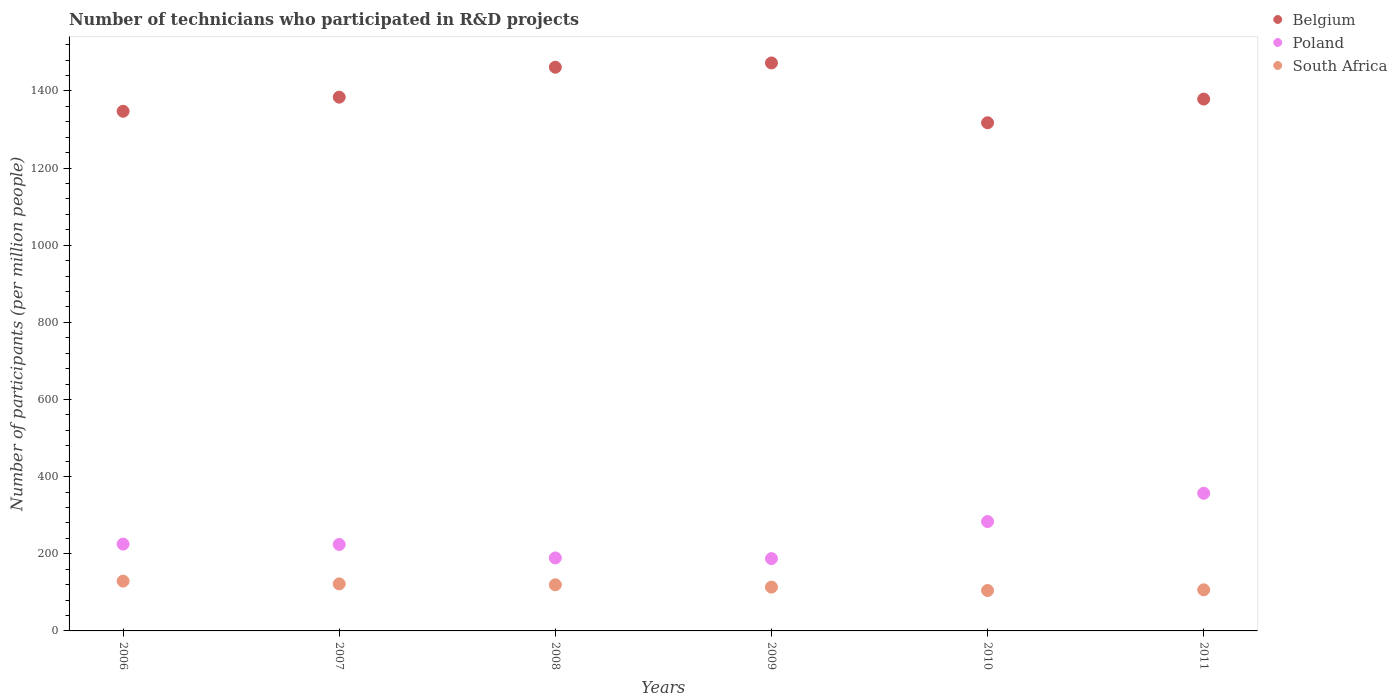What is the number of technicians who participated in R&D projects in South Africa in 2009?
Make the answer very short. 113.59. Across all years, what is the maximum number of technicians who participated in R&D projects in Belgium?
Provide a short and direct response. 1472.61. Across all years, what is the minimum number of technicians who participated in R&D projects in Poland?
Ensure brevity in your answer.  187.5. What is the total number of technicians who participated in R&D projects in Poland in the graph?
Your response must be concise. 1466.48. What is the difference between the number of technicians who participated in R&D projects in Belgium in 2006 and that in 2009?
Make the answer very short. -125.25. What is the difference between the number of technicians who participated in R&D projects in Poland in 2006 and the number of technicians who participated in R&D projects in South Africa in 2011?
Provide a succinct answer. 118.53. What is the average number of technicians who participated in R&D projects in South Africa per year?
Give a very brief answer. 115.94. In the year 2006, what is the difference between the number of technicians who participated in R&D projects in Poland and number of technicians who participated in R&D projects in Belgium?
Your answer should be compact. -1122.26. What is the ratio of the number of technicians who participated in R&D projects in Belgium in 2006 to that in 2009?
Give a very brief answer. 0.91. Is the number of technicians who participated in R&D projects in Poland in 2009 less than that in 2010?
Give a very brief answer. Yes. Is the difference between the number of technicians who participated in R&D projects in Poland in 2006 and 2009 greater than the difference between the number of technicians who participated in R&D projects in Belgium in 2006 and 2009?
Provide a succinct answer. Yes. What is the difference between the highest and the second highest number of technicians who participated in R&D projects in Belgium?
Provide a succinct answer. 11.08. What is the difference between the highest and the lowest number of technicians who participated in R&D projects in South Africa?
Your answer should be very brief. 24.35. In how many years, is the number of technicians who participated in R&D projects in Poland greater than the average number of technicians who participated in R&D projects in Poland taken over all years?
Your response must be concise. 2. Is the number of technicians who participated in R&D projects in Poland strictly less than the number of technicians who participated in R&D projects in South Africa over the years?
Provide a short and direct response. No. How many years are there in the graph?
Keep it short and to the point. 6. What is the difference between two consecutive major ticks on the Y-axis?
Ensure brevity in your answer.  200. Does the graph contain grids?
Provide a short and direct response. No. How are the legend labels stacked?
Your response must be concise. Vertical. What is the title of the graph?
Give a very brief answer. Number of technicians who participated in R&D projects. What is the label or title of the Y-axis?
Ensure brevity in your answer.  Number of participants (per million people). What is the Number of participants (per million people) in Belgium in 2006?
Your response must be concise. 1347.37. What is the Number of participants (per million people) in Poland in 2006?
Offer a very short reply. 225.1. What is the Number of participants (per million people) in South Africa in 2006?
Give a very brief answer. 129.14. What is the Number of participants (per million people) in Belgium in 2007?
Provide a short and direct response. 1383.94. What is the Number of participants (per million people) in Poland in 2007?
Give a very brief answer. 224.18. What is the Number of participants (per million people) of South Africa in 2007?
Make the answer very short. 121.96. What is the Number of participants (per million people) in Belgium in 2008?
Ensure brevity in your answer.  1461.53. What is the Number of participants (per million people) in Poland in 2008?
Your answer should be very brief. 189.22. What is the Number of participants (per million people) of South Africa in 2008?
Your response must be concise. 119.61. What is the Number of participants (per million people) of Belgium in 2009?
Keep it short and to the point. 1472.61. What is the Number of participants (per million people) in Poland in 2009?
Give a very brief answer. 187.5. What is the Number of participants (per million people) in South Africa in 2009?
Offer a terse response. 113.59. What is the Number of participants (per million people) of Belgium in 2010?
Provide a succinct answer. 1317.54. What is the Number of participants (per million people) of Poland in 2010?
Offer a terse response. 283.57. What is the Number of participants (per million people) of South Africa in 2010?
Provide a short and direct response. 104.79. What is the Number of participants (per million people) in Belgium in 2011?
Keep it short and to the point. 1378.98. What is the Number of participants (per million people) in Poland in 2011?
Your answer should be very brief. 356.91. What is the Number of participants (per million people) in South Africa in 2011?
Your answer should be very brief. 106.57. Across all years, what is the maximum Number of participants (per million people) in Belgium?
Provide a succinct answer. 1472.61. Across all years, what is the maximum Number of participants (per million people) of Poland?
Your answer should be compact. 356.91. Across all years, what is the maximum Number of participants (per million people) in South Africa?
Keep it short and to the point. 129.14. Across all years, what is the minimum Number of participants (per million people) of Belgium?
Keep it short and to the point. 1317.54. Across all years, what is the minimum Number of participants (per million people) in Poland?
Your answer should be very brief. 187.5. Across all years, what is the minimum Number of participants (per million people) in South Africa?
Keep it short and to the point. 104.79. What is the total Number of participants (per million people) of Belgium in the graph?
Provide a succinct answer. 8361.97. What is the total Number of participants (per million people) in Poland in the graph?
Offer a terse response. 1466.48. What is the total Number of participants (per million people) of South Africa in the graph?
Provide a succinct answer. 695.67. What is the difference between the Number of participants (per million people) of Belgium in 2006 and that in 2007?
Offer a terse response. -36.57. What is the difference between the Number of participants (per million people) of Poland in 2006 and that in 2007?
Offer a terse response. 0.92. What is the difference between the Number of participants (per million people) of South Africa in 2006 and that in 2007?
Offer a very short reply. 7.19. What is the difference between the Number of participants (per million people) in Belgium in 2006 and that in 2008?
Offer a terse response. -114.17. What is the difference between the Number of participants (per million people) in Poland in 2006 and that in 2008?
Provide a succinct answer. 35.88. What is the difference between the Number of participants (per million people) of South Africa in 2006 and that in 2008?
Ensure brevity in your answer.  9.53. What is the difference between the Number of participants (per million people) of Belgium in 2006 and that in 2009?
Keep it short and to the point. -125.25. What is the difference between the Number of participants (per million people) of Poland in 2006 and that in 2009?
Your answer should be very brief. 37.6. What is the difference between the Number of participants (per million people) of South Africa in 2006 and that in 2009?
Your response must be concise. 15.55. What is the difference between the Number of participants (per million people) in Belgium in 2006 and that in 2010?
Offer a terse response. 29.83. What is the difference between the Number of participants (per million people) in Poland in 2006 and that in 2010?
Offer a terse response. -58.47. What is the difference between the Number of participants (per million people) in South Africa in 2006 and that in 2010?
Keep it short and to the point. 24.35. What is the difference between the Number of participants (per million people) of Belgium in 2006 and that in 2011?
Your response must be concise. -31.62. What is the difference between the Number of participants (per million people) in Poland in 2006 and that in 2011?
Provide a succinct answer. -131.81. What is the difference between the Number of participants (per million people) of South Africa in 2006 and that in 2011?
Give a very brief answer. 22.58. What is the difference between the Number of participants (per million people) in Belgium in 2007 and that in 2008?
Give a very brief answer. -77.6. What is the difference between the Number of participants (per million people) in Poland in 2007 and that in 2008?
Offer a terse response. 34.96. What is the difference between the Number of participants (per million people) of South Africa in 2007 and that in 2008?
Offer a very short reply. 2.34. What is the difference between the Number of participants (per million people) of Belgium in 2007 and that in 2009?
Provide a short and direct response. -88.68. What is the difference between the Number of participants (per million people) of Poland in 2007 and that in 2009?
Make the answer very short. 36.67. What is the difference between the Number of participants (per million people) in South Africa in 2007 and that in 2009?
Keep it short and to the point. 8.37. What is the difference between the Number of participants (per million people) of Belgium in 2007 and that in 2010?
Offer a terse response. 66.4. What is the difference between the Number of participants (per million people) in Poland in 2007 and that in 2010?
Your answer should be very brief. -59.39. What is the difference between the Number of participants (per million people) of South Africa in 2007 and that in 2010?
Ensure brevity in your answer.  17.16. What is the difference between the Number of participants (per million people) of Belgium in 2007 and that in 2011?
Your answer should be compact. 4.95. What is the difference between the Number of participants (per million people) in Poland in 2007 and that in 2011?
Provide a short and direct response. -132.73. What is the difference between the Number of participants (per million people) of South Africa in 2007 and that in 2011?
Ensure brevity in your answer.  15.39. What is the difference between the Number of participants (per million people) of Belgium in 2008 and that in 2009?
Offer a very short reply. -11.08. What is the difference between the Number of participants (per million people) in Poland in 2008 and that in 2009?
Keep it short and to the point. 1.72. What is the difference between the Number of participants (per million people) of South Africa in 2008 and that in 2009?
Offer a very short reply. 6.02. What is the difference between the Number of participants (per million people) of Belgium in 2008 and that in 2010?
Your answer should be compact. 144. What is the difference between the Number of participants (per million people) of Poland in 2008 and that in 2010?
Make the answer very short. -94.35. What is the difference between the Number of participants (per million people) in South Africa in 2008 and that in 2010?
Offer a very short reply. 14.82. What is the difference between the Number of participants (per million people) in Belgium in 2008 and that in 2011?
Your answer should be compact. 82.55. What is the difference between the Number of participants (per million people) of Poland in 2008 and that in 2011?
Give a very brief answer. -167.68. What is the difference between the Number of participants (per million people) in South Africa in 2008 and that in 2011?
Your response must be concise. 13.04. What is the difference between the Number of participants (per million people) in Belgium in 2009 and that in 2010?
Your answer should be very brief. 155.08. What is the difference between the Number of participants (per million people) of Poland in 2009 and that in 2010?
Offer a terse response. -96.07. What is the difference between the Number of participants (per million people) of South Africa in 2009 and that in 2010?
Give a very brief answer. 8.8. What is the difference between the Number of participants (per million people) of Belgium in 2009 and that in 2011?
Your response must be concise. 93.63. What is the difference between the Number of participants (per million people) in Poland in 2009 and that in 2011?
Ensure brevity in your answer.  -169.4. What is the difference between the Number of participants (per million people) of South Africa in 2009 and that in 2011?
Offer a very short reply. 7.02. What is the difference between the Number of participants (per million people) of Belgium in 2010 and that in 2011?
Make the answer very short. -61.45. What is the difference between the Number of participants (per million people) in Poland in 2010 and that in 2011?
Give a very brief answer. -73.34. What is the difference between the Number of participants (per million people) of South Africa in 2010 and that in 2011?
Offer a very short reply. -1.78. What is the difference between the Number of participants (per million people) in Belgium in 2006 and the Number of participants (per million people) in Poland in 2007?
Ensure brevity in your answer.  1123.19. What is the difference between the Number of participants (per million people) of Belgium in 2006 and the Number of participants (per million people) of South Africa in 2007?
Offer a terse response. 1225.41. What is the difference between the Number of participants (per million people) in Poland in 2006 and the Number of participants (per million people) in South Africa in 2007?
Provide a succinct answer. 103.14. What is the difference between the Number of participants (per million people) of Belgium in 2006 and the Number of participants (per million people) of Poland in 2008?
Your answer should be very brief. 1158.14. What is the difference between the Number of participants (per million people) in Belgium in 2006 and the Number of participants (per million people) in South Africa in 2008?
Provide a short and direct response. 1227.75. What is the difference between the Number of participants (per million people) of Poland in 2006 and the Number of participants (per million people) of South Africa in 2008?
Your answer should be compact. 105.49. What is the difference between the Number of participants (per million people) in Belgium in 2006 and the Number of participants (per million people) in Poland in 2009?
Offer a very short reply. 1159.86. What is the difference between the Number of participants (per million people) of Belgium in 2006 and the Number of participants (per million people) of South Africa in 2009?
Provide a short and direct response. 1233.78. What is the difference between the Number of participants (per million people) in Poland in 2006 and the Number of participants (per million people) in South Africa in 2009?
Keep it short and to the point. 111.51. What is the difference between the Number of participants (per million people) of Belgium in 2006 and the Number of participants (per million people) of Poland in 2010?
Ensure brevity in your answer.  1063.8. What is the difference between the Number of participants (per million people) of Belgium in 2006 and the Number of participants (per million people) of South Africa in 2010?
Provide a short and direct response. 1242.57. What is the difference between the Number of participants (per million people) of Poland in 2006 and the Number of participants (per million people) of South Africa in 2010?
Offer a terse response. 120.31. What is the difference between the Number of participants (per million people) of Belgium in 2006 and the Number of participants (per million people) of Poland in 2011?
Keep it short and to the point. 990.46. What is the difference between the Number of participants (per million people) of Belgium in 2006 and the Number of participants (per million people) of South Africa in 2011?
Offer a very short reply. 1240.8. What is the difference between the Number of participants (per million people) of Poland in 2006 and the Number of participants (per million people) of South Africa in 2011?
Give a very brief answer. 118.53. What is the difference between the Number of participants (per million people) in Belgium in 2007 and the Number of participants (per million people) in Poland in 2008?
Provide a short and direct response. 1194.72. What is the difference between the Number of participants (per million people) of Belgium in 2007 and the Number of participants (per million people) of South Africa in 2008?
Offer a terse response. 1264.32. What is the difference between the Number of participants (per million people) in Poland in 2007 and the Number of participants (per million people) in South Africa in 2008?
Make the answer very short. 104.56. What is the difference between the Number of participants (per million people) of Belgium in 2007 and the Number of participants (per million people) of Poland in 2009?
Offer a terse response. 1196.43. What is the difference between the Number of participants (per million people) of Belgium in 2007 and the Number of participants (per million people) of South Africa in 2009?
Keep it short and to the point. 1270.35. What is the difference between the Number of participants (per million people) of Poland in 2007 and the Number of participants (per million people) of South Africa in 2009?
Your answer should be compact. 110.59. What is the difference between the Number of participants (per million people) of Belgium in 2007 and the Number of participants (per million people) of Poland in 2010?
Provide a succinct answer. 1100.37. What is the difference between the Number of participants (per million people) in Belgium in 2007 and the Number of participants (per million people) in South Africa in 2010?
Offer a very short reply. 1279.14. What is the difference between the Number of participants (per million people) of Poland in 2007 and the Number of participants (per million people) of South Africa in 2010?
Make the answer very short. 119.38. What is the difference between the Number of participants (per million people) in Belgium in 2007 and the Number of participants (per million people) in Poland in 2011?
Keep it short and to the point. 1027.03. What is the difference between the Number of participants (per million people) in Belgium in 2007 and the Number of participants (per million people) in South Africa in 2011?
Provide a short and direct response. 1277.37. What is the difference between the Number of participants (per million people) of Poland in 2007 and the Number of participants (per million people) of South Africa in 2011?
Make the answer very short. 117.61. What is the difference between the Number of participants (per million people) in Belgium in 2008 and the Number of participants (per million people) in Poland in 2009?
Your answer should be very brief. 1274.03. What is the difference between the Number of participants (per million people) in Belgium in 2008 and the Number of participants (per million people) in South Africa in 2009?
Give a very brief answer. 1347.94. What is the difference between the Number of participants (per million people) in Poland in 2008 and the Number of participants (per million people) in South Africa in 2009?
Your answer should be very brief. 75.63. What is the difference between the Number of participants (per million people) of Belgium in 2008 and the Number of participants (per million people) of Poland in 2010?
Give a very brief answer. 1177.97. What is the difference between the Number of participants (per million people) in Belgium in 2008 and the Number of participants (per million people) in South Africa in 2010?
Keep it short and to the point. 1356.74. What is the difference between the Number of participants (per million people) of Poland in 2008 and the Number of participants (per million people) of South Africa in 2010?
Your answer should be compact. 84.43. What is the difference between the Number of participants (per million people) of Belgium in 2008 and the Number of participants (per million people) of Poland in 2011?
Offer a terse response. 1104.63. What is the difference between the Number of participants (per million people) in Belgium in 2008 and the Number of participants (per million people) in South Africa in 2011?
Provide a succinct answer. 1354.97. What is the difference between the Number of participants (per million people) of Poland in 2008 and the Number of participants (per million people) of South Africa in 2011?
Offer a very short reply. 82.65. What is the difference between the Number of participants (per million people) of Belgium in 2009 and the Number of participants (per million people) of Poland in 2010?
Offer a very short reply. 1189.04. What is the difference between the Number of participants (per million people) of Belgium in 2009 and the Number of participants (per million people) of South Africa in 2010?
Your answer should be very brief. 1367.82. What is the difference between the Number of participants (per million people) in Poland in 2009 and the Number of participants (per million people) in South Africa in 2010?
Provide a short and direct response. 82.71. What is the difference between the Number of participants (per million people) in Belgium in 2009 and the Number of participants (per million people) in Poland in 2011?
Give a very brief answer. 1115.71. What is the difference between the Number of participants (per million people) of Belgium in 2009 and the Number of participants (per million people) of South Africa in 2011?
Ensure brevity in your answer.  1366.04. What is the difference between the Number of participants (per million people) of Poland in 2009 and the Number of participants (per million people) of South Africa in 2011?
Ensure brevity in your answer.  80.93. What is the difference between the Number of participants (per million people) in Belgium in 2010 and the Number of participants (per million people) in Poland in 2011?
Make the answer very short. 960.63. What is the difference between the Number of participants (per million people) in Belgium in 2010 and the Number of participants (per million people) in South Africa in 2011?
Provide a succinct answer. 1210.97. What is the difference between the Number of participants (per million people) of Poland in 2010 and the Number of participants (per million people) of South Africa in 2011?
Provide a short and direct response. 177. What is the average Number of participants (per million people) in Belgium per year?
Your response must be concise. 1393.66. What is the average Number of participants (per million people) of Poland per year?
Keep it short and to the point. 244.41. What is the average Number of participants (per million people) of South Africa per year?
Provide a succinct answer. 115.94. In the year 2006, what is the difference between the Number of participants (per million people) of Belgium and Number of participants (per million people) of Poland?
Your answer should be very brief. 1122.26. In the year 2006, what is the difference between the Number of participants (per million people) of Belgium and Number of participants (per million people) of South Africa?
Provide a short and direct response. 1218.22. In the year 2006, what is the difference between the Number of participants (per million people) of Poland and Number of participants (per million people) of South Africa?
Provide a succinct answer. 95.96. In the year 2007, what is the difference between the Number of participants (per million people) in Belgium and Number of participants (per million people) in Poland?
Your answer should be compact. 1159.76. In the year 2007, what is the difference between the Number of participants (per million people) of Belgium and Number of participants (per million people) of South Africa?
Offer a terse response. 1261.98. In the year 2007, what is the difference between the Number of participants (per million people) in Poland and Number of participants (per million people) in South Africa?
Provide a short and direct response. 102.22. In the year 2008, what is the difference between the Number of participants (per million people) of Belgium and Number of participants (per million people) of Poland?
Make the answer very short. 1272.31. In the year 2008, what is the difference between the Number of participants (per million people) of Belgium and Number of participants (per million people) of South Africa?
Give a very brief answer. 1341.92. In the year 2008, what is the difference between the Number of participants (per million people) in Poland and Number of participants (per million people) in South Africa?
Your response must be concise. 69.61. In the year 2009, what is the difference between the Number of participants (per million people) in Belgium and Number of participants (per million people) in Poland?
Your answer should be very brief. 1285.11. In the year 2009, what is the difference between the Number of participants (per million people) of Belgium and Number of participants (per million people) of South Africa?
Offer a very short reply. 1359.02. In the year 2009, what is the difference between the Number of participants (per million people) of Poland and Number of participants (per million people) of South Africa?
Your answer should be very brief. 73.91. In the year 2010, what is the difference between the Number of participants (per million people) of Belgium and Number of participants (per million people) of Poland?
Provide a succinct answer. 1033.97. In the year 2010, what is the difference between the Number of participants (per million people) in Belgium and Number of participants (per million people) in South Africa?
Offer a terse response. 1212.74. In the year 2010, what is the difference between the Number of participants (per million people) of Poland and Number of participants (per million people) of South Africa?
Your response must be concise. 178.78. In the year 2011, what is the difference between the Number of participants (per million people) of Belgium and Number of participants (per million people) of Poland?
Keep it short and to the point. 1022.08. In the year 2011, what is the difference between the Number of participants (per million people) in Belgium and Number of participants (per million people) in South Africa?
Ensure brevity in your answer.  1272.41. In the year 2011, what is the difference between the Number of participants (per million people) in Poland and Number of participants (per million people) in South Africa?
Offer a terse response. 250.34. What is the ratio of the Number of participants (per million people) in Belgium in 2006 to that in 2007?
Offer a very short reply. 0.97. What is the ratio of the Number of participants (per million people) in South Africa in 2006 to that in 2007?
Your answer should be compact. 1.06. What is the ratio of the Number of participants (per million people) in Belgium in 2006 to that in 2008?
Offer a very short reply. 0.92. What is the ratio of the Number of participants (per million people) of Poland in 2006 to that in 2008?
Make the answer very short. 1.19. What is the ratio of the Number of participants (per million people) in South Africa in 2006 to that in 2008?
Your response must be concise. 1.08. What is the ratio of the Number of participants (per million people) in Belgium in 2006 to that in 2009?
Provide a succinct answer. 0.91. What is the ratio of the Number of participants (per million people) of Poland in 2006 to that in 2009?
Make the answer very short. 1.2. What is the ratio of the Number of participants (per million people) of South Africa in 2006 to that in 2009?
Provide a succinct answer. 1.14. What is the ratio of the Number of participants (per million people) in Belgium in 2006 to that in 2010?
Give a very brief answer. 1.02. What is the ratio of the Number of participants (per million people) in Poland in 2006 to that in 2010?
Keep it short and to the point. 0.79. What is the ratio of the Number of participants (per million people) of South Africa in 2006 to that in 2010?
Keep it short and to the point. 1.23. What is the ratio of the Number of participants (per million people) in Belgium in 2006 to that in 2011?
Offer a very short reply. 0.98. What is the ratio of the Number of participants (per million people) of Poland in 2006 to that in 2011?
Provide a succinct answer. 0.63. What is the ratio of the Number of participants (per million people) in South Africa in 2006 to that in 2011?
Give a very brief answer. 1.21. What is the ratio of the Number of participants (per million people) of Belgium in 2007 to that in 2008?
Offer a terse response. 0.95. What is the ratio of the Number of participants (per million people) in Poland in 2007 to that in 2008?
Your response must be concise. 1.18. What is the ratio of the Number of participants (per million people) in South Africa in 2007 to that in 2008?
Your answer should be compact. 1.02. What is the ratio of the Number of participants (per million people) of Belgium in 2007 to that in 2009?
Offer a very short reply. 0.94. What is the ratio of the Number of participants (per million people) in Poland in 2007 to that in 2009?
Provide a short and direct response. 1.2. What is the ratio of the Number of participants (per million people) in South Africa in 2007 to that in 2009?
Offer a terse response. 1.07. What is the ratio of the Number of participants (per million people) in Belgium in 2007 to that in 2010?
Offer a terse response. 1.05. What is the ratio of the Number of participants (per million people) of Poland in 2007 to that in 2010?
Your response must be concise. 0.79. What is the ratio of the Number of participants (per million people) of South Africa in 2007 to that in 2010?
Offer a terse response. 1.16. What is the ratio of the Number of participants (per million people) of Belgium in 2007 to that in 2011?
Your response must be concise. 1. What is the ratio of the Number of participants (per million people) of Poland in 2007 to that in 2011?
Give a very brief answer. 0.63. What is the ratio of the Number of participants (per million people) of South Africa in 2007 to that in 2011?
Make the answer very short. 1.14. What is the ratio of the Number of participants (per million people) of Poland in 2008 to that in 2009?
Give a very brief answer. 1.01. What is the ratio of the Number of participants (per million people) of South Africa in 2008 to that in 2009?
Give a very brief answer. 1.05. What is the ratio of the Number of participants (per million people) in Belgium in 2008 to that in 2010?
Provide a succinct answer. 1.11. What is the ratio of the Number of participants (per million people) in Poland in 2008 to that in 2010?
Provide a succinct answer. 0.67. What is the ratio of the Number of participants (per million people) of South Africa in 2008 to that in 2010?
Offer a very short reply. 1.14. What is the ratio of the Number of participants (per million people) of Belgium in 2008 to that in 2011?
Offer a terse response. 1.06. What is the ratio of the Number of participants (per million people) in Poland in 2008 to that in 2011?
Your response must be concise. 0.53. What is the ratio of the Number of participants (per million people) of South Africa in 2008 to that in 2011?
Provide a short and direct response. 1.12. What is the ratio of the Number of participants (per million people) of Belgium in 2009 to that in 2010?
Make the answer very short. 1.12. What is the ratio of the Number of participants (per million people) in Poland in 2009 to that in 2010?
Make the answer very short. 0.66. What is the ratio of the Number of participants (per million people) of South Africa in 2009 to that in 2010?
Provide a short and direct response. 1.08. What is the ratio of the Number of participants (per million people) in Belgium in 2009 to that in 2011?
Offer a very short reply. 1.07. What is the ratio of the Number of participants (per million people) in Poland in 2009 to that in 2011?
Keep it short and to the point. 0.53. What is the ratio of the Number of participants (per million people) of South Africa in 2009 to that in 2011?
Offer a terse response. 1.07. What is the ratio of the Number of participants (per million people) in Belgium in 2010 to that in 2011?
Keep it short and to the point. 0.96. What is the ratio of the Number of participants (per million people) of Poland in 2010 to that in 2011?
Provide a succinct answer. 0.79. What is the ratio of the Number of participants (per million people) in South Africa in 2010 to that in 2011?
Offer a very short reply. 0.98. What is the difference between the highest and the second highest Number of participants (per million people) in Belgium?
Provide a short and direct response. 11.08. What is the difference between the highest and the second highest Number of participants (per million people) of Poland?
Ensure brevity in your answer.  73.34. What is the difference between the highest and the second highest Number of participants (per million people) in South Africa?
Make the answer very short. 7.19. What is the difference between the highest and the lowest Number of participants (per million people) of Belgium?
Give a very brief answer. 155.08. What is the difference between the highest and the lowest Number of participants (per million people) of Poland?
Your answer should be very brief. 169.4. What is the difference between the highest and the lowest Number of participants (per million people) of South Africa?
Provide a short and direct response. 24.35. 